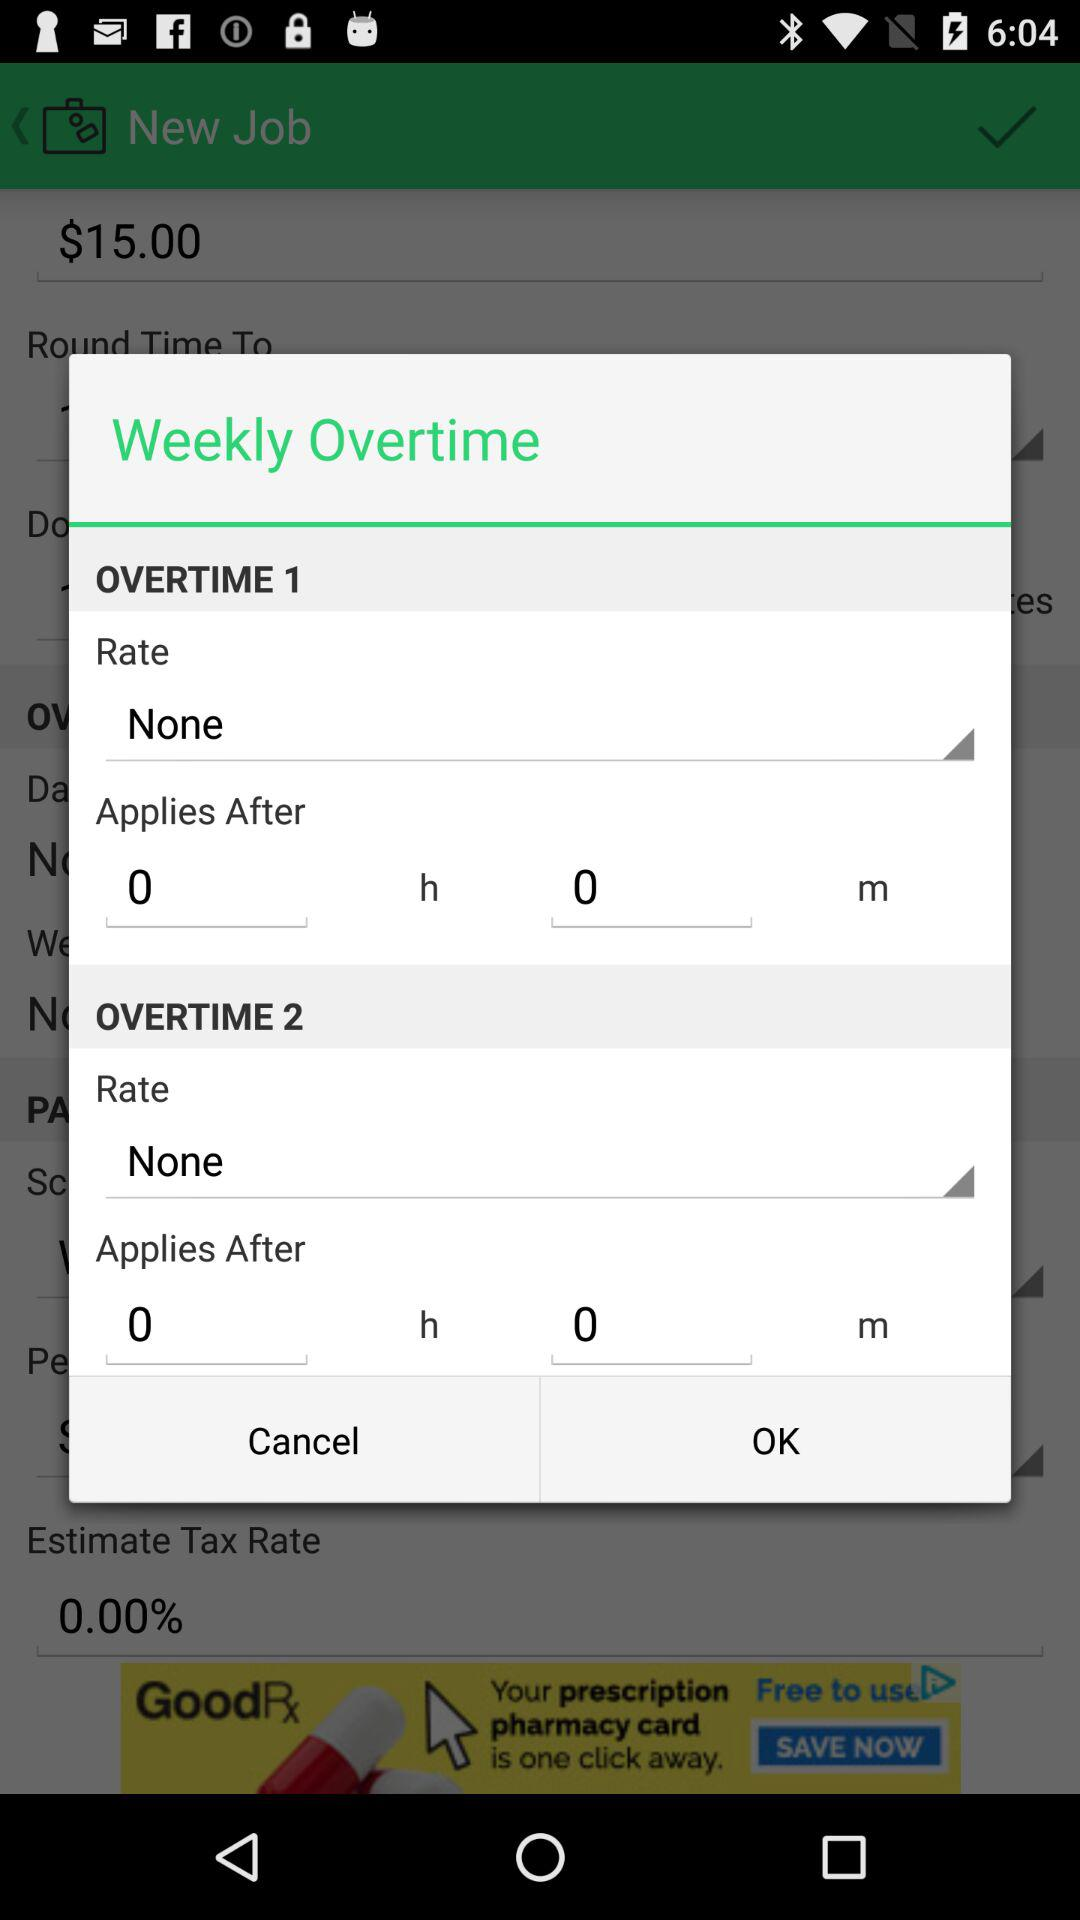What rate is selected in "OVERTIME 1"? The selected rate is "None". 